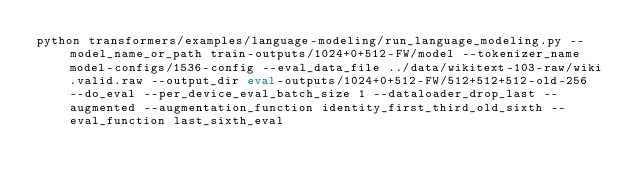<code> <loc_0><loc_0><loc_500><loc_500><_Bash_>python transformers/examples/language-modeling/run_language_modeling.py --model_name_or_path train-outputs/1024+0+512-FW/model --tokenizer_name model-configs/1536-config --eval_data_file ../data/wikitext-103-raw/wiki.valid.raw --output_dir eval-outputs/1024+0+512-FW/512+512+512-old-256 --do_eval --per_device_eval_batch_size 1 --dataloader_drop_last --augmented --augmentation_function identity_first_third_old_sixth --eval_function last_sixth_eval</code> 